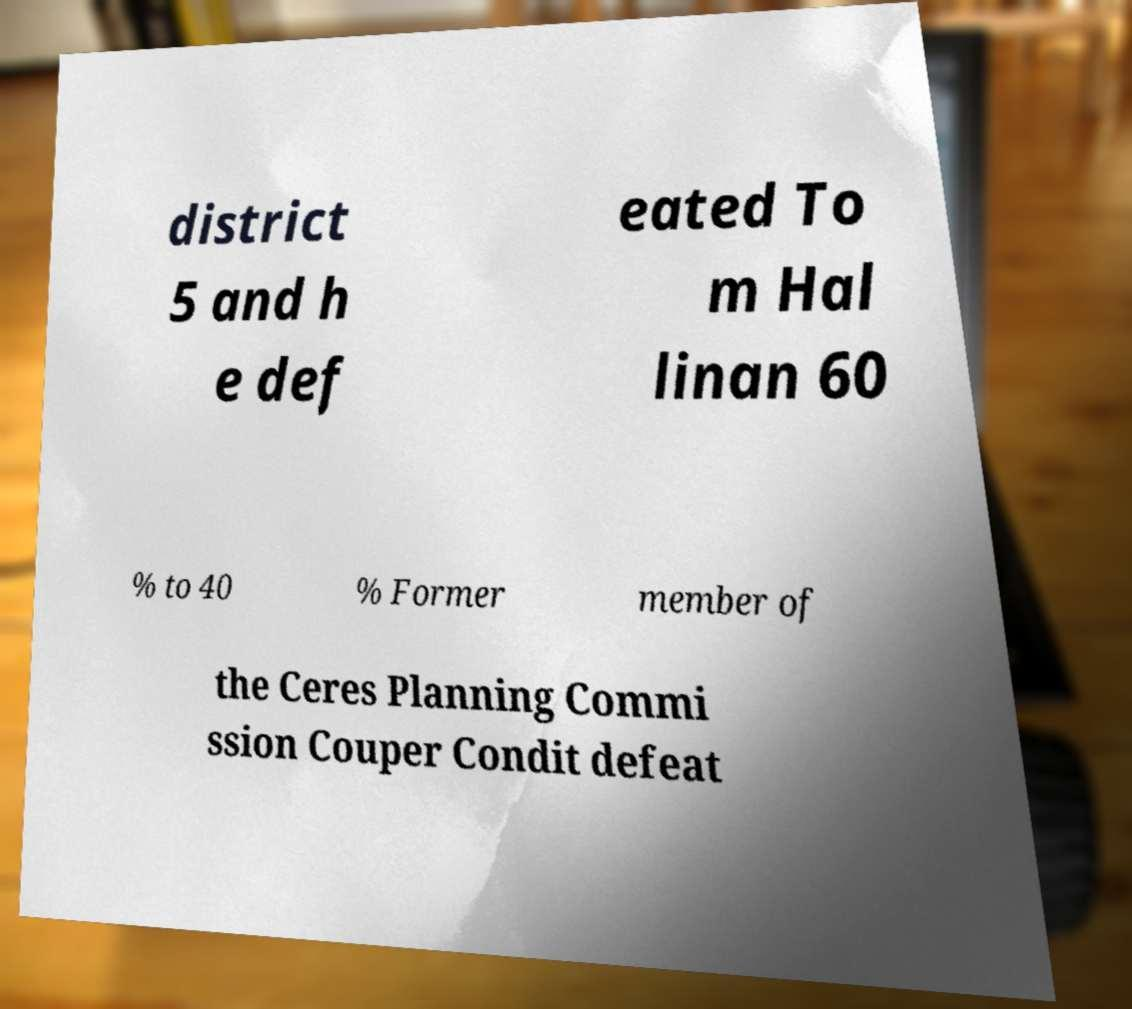Can you read and provide the text displayed in the image?This photo seems to have some interesting text. Can you extract and type it out for me? district 5 and h e def eated To m Hal linan 60 % to 40 % Former member of the Ceres Planning Commi ssion Couper Condit defeat 